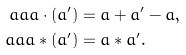<formula> <loc_0><loc_0><loc_500><loc_500>\ a a a \cdot ( a ^ { \prime } ) & = a + a ^ { \prime } - a , \\ \ a a a * ( a ^ { \prime } ) & = a * a ^ { \prime } .</formula> 